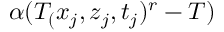<formula> <loc_0><loc_0><loc_500><loc_500>\alpha ( T _ { ( } x _ { j } , z _ { j } , t _ { j } ) ^ { r } - T )</formula> 